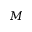<formula> <loc_0><loc_0><loc_500><loc_500>M</formula> 